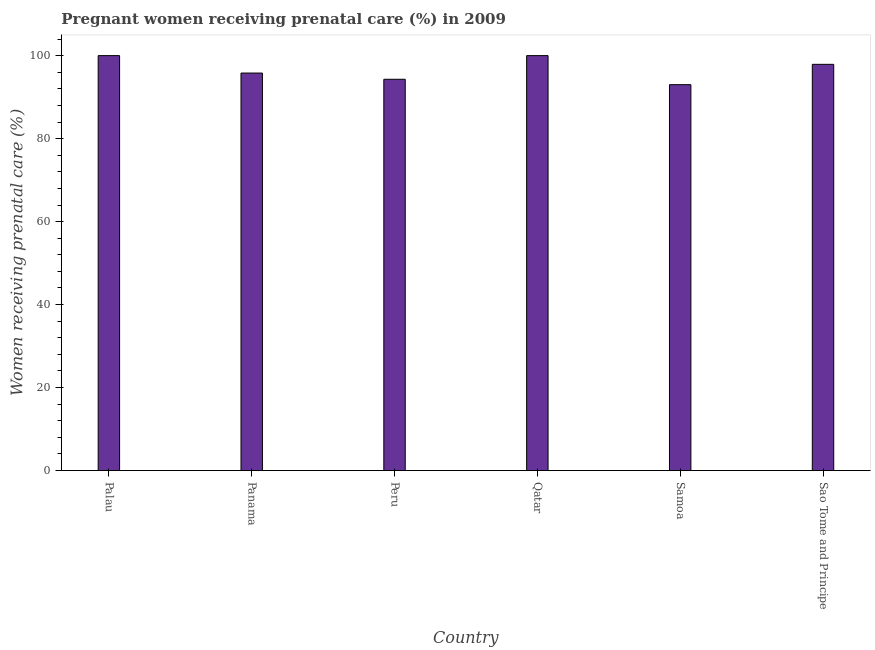Does the graph contain any zero values?
Ensure brevity in your answer.  No. What is the title of the graph?
Offer a very short reply. Pregnant women receiving prenatal care (%) in 2009. What is the label or title of the X-axis?
Offer a terse response. Country. What is the label or title of the Y-axis?
Provide a short and direct response. Women receiving prenatal care (%). Across all countries, what is the minimum percentage of pregnant women receiving prenatal care?
Provide a short and direct response. 93. In which country was the percentage of pregnant women receiving prenatal care maximum?
Make the answer very short. Palau. In which country was the percentage of pregnant women receiving prenatal care minimum?
Your response must be concise. Samoa. What is the sum of the percentage of pregnant women receiving prenatal care?
Make the answer very short. 581. What is the difference between the percentage of pregnant women receiving prenatal care in Palau and Panama?
Your answer should be very brief. 4.2. What is the average percentage of pregnant women receiving prenatal care per country?
Keep it short and to the point. 96.83. What is the median percentage of pregnant women receiving prenatal care?
Ensure brevity in your answer.  96.85. In how many countries, is the percentage of pregnant women receiving prenatal care greater than 64 %?
Provide a short and direct response. 6. What is the ratio of the percentage of pregnant women receiving prenatal care in Panama to that in Qatar?
Your response must be concise. 0.96. Is the difference between the percentage of pregnant women receiving prenatal care in Palau and Qatar greater than the difference between any two countries?
Your response must be concise. No. Is the sum of the percentage of pregnant women receiving prenatal care in Samoa and Sao Tome and Principe greater than the maximum percentage of pregnant women receiving prenatal care across all countries?
Your answer should be very brief. Yes. What is the difference between the highest and the lowest percentage of pregnant women receiving prenatal care?
Your answer should be compact. 7. In how many countries, is the percentage of pregnant women receiving prenatal care greater than the average percentage of pregnant women receiving prenatal care taken over all countries?
Keep it short and to the point. 3. How many countries are there in the graph?
Offer a terse response. 6. What is the Women receiving prenatal care (%) in Palau?
Provide a short and direct response. 100. What is the Women receiving prenatal care (%) in Panama?
Offer a very short reply. 95.8. What is the Women receiving prenatal care (%) of Peru?
Offer a terse response. 94.3. What is the Women receiving prenatal care (%) of Qatar?
Offer a terse response. 100. What is the Women receiving prenatal care (%) of Samoa?
Give a very brief answer. 93. What is the Women receiving prenatal care (%) of Sao Tome and Principe?
Provide a succinct answer. 97.9. What is the difference between the Women receiving prenatal care (%) in Palau and Panama?
Offer a terse response. 4.2. What is the difference between the Women receiving prenatal care (%) in Palau and Qatar?
Make the answer very short. 0. What is the difference between the Women receiving prenatal care (%) in Palau and Sao Tome and Principe?
Your answer should be very brief. 2.1. What is the difference between the Women receiving prenatal care (%) in Panama and Peru?
Your response must be concise. 1.5. What is the difference between the Women receiving prenatal care (%) in Panama and Qatar?
Your response must be concise. -4.2. What is the difference between the Women receiving prenatal care (%) in Panama and Samoa?
Make the answer very short. 2.8. What is the difference between the Women receiving prenatal care (%) in Panama and Sao Tome and Principe?
Make the answer very short. -2.1. What is the difference between the Women receiving prenatal care (%) in Peru and Samoa?
Provide a succinct answer. 1.3. What is the difference between the Women receiving prenatal care (%) in Qatar and Sao Tome and Principe?
Provide a short and direct response. 2.1. What is the ratio of the Women receiving prenatal care (%) in Palau to that in Panama?
Your answer should be very brief. 1.04. What is the ratio of the Women receiving prenatal care (%) in Palau to that in Peru?
Provide a succinct answer. 1.06. What is the ratio of the Women receiving prenatal care (%) in Palau to that in Qatar?
Ensure brevity in your answer.  1. What is the ratio of the Women receiving prenatal care (%) in Palau to that in Samoa?
Your answer should be compact. 1.07. What is the ratio of the Women receiving prenatal care (%) in Palau to that in Sao Tome and Principe?
Make the answer very short. 1.02. What is the ratio of the Women receiving prenatal care (%) in Panama to that in Peru?
Your answer should be very brief. 1.02. What is the ratio of the Women receiving prenatal care (%) in Panama to that in Qatar?
Ensure brevity in your answer.  0.96. What is the ratio of the Women receiving prenatal care (%) in Panama to that in Samoa?
Offer a terse response. 1.03. What is the ratio of the Women receiving prenatal care (%) in Panama to that in Sao Tome and Principe?
Keep it short and to the point. 0.98. What is the ratio of the Women receiving prenatal care (%) in Peru to that in Qatar?
Offer a terse response. 0.94. What is the ratio of the Women receiving prenatal care (%) in Peru to that in Sao Tome and Principe?
Offer a very short reply. 0.96. What is the ratio of the Women receiving prenatal care (%) in Qatar to that in Samoa?
Provide a succinct answer. 1.07. What is the ratio of the Women receiving prenatal care (%) in Qatar to that in Sao Tome and Principe?
Offer a terse response. 1.02. What is the ratio of the Women receiving prenatal care (%) in Samoa to that in Sao Tome and Principe?
Make the answer very short. 0.95. 